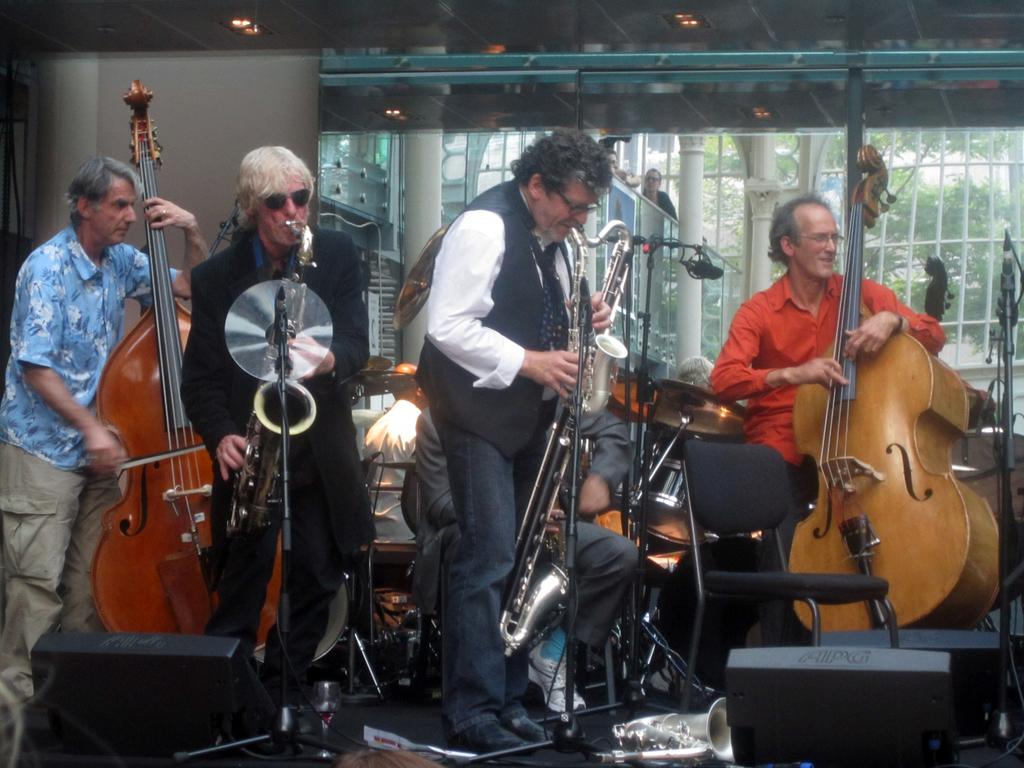How many people are in the image? There are 5 men in the image. What are the men doing in the image? Each man is holding a musical instrument. What else can be seen in the image besides the men and their instruments? There are equipment visible in the image. What type of lighting is present in the background of the image? There are lights on the ceiling in the background of the image. What discovery did the sister make in the image? There is no sister or discovery present in the image. What type of ray is visible in the image? There is no ray visible in the image. 